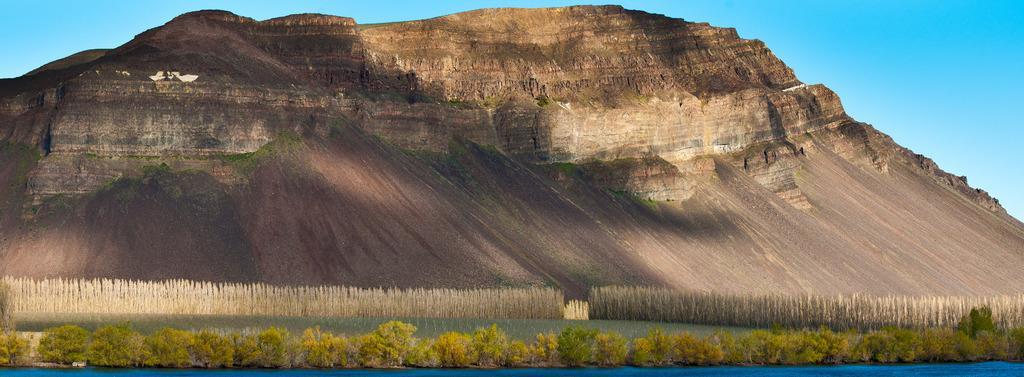How would you summarize this image in a sentence or two? In the picture I can see the hills. I can see the plants at the bottom of the picture. There are clouds in the sky. 